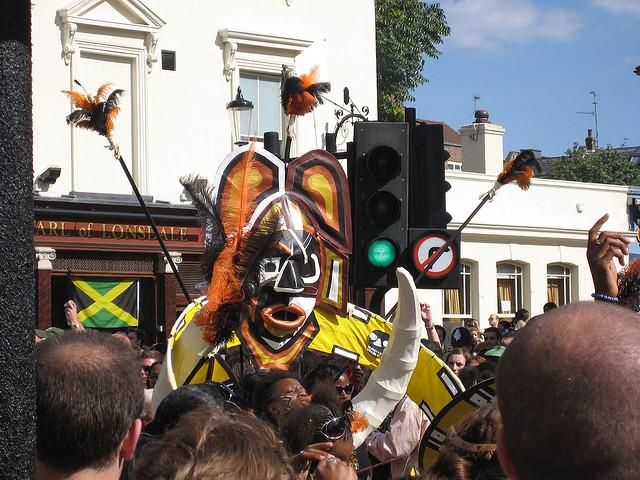The flag of what nation is visible in the background?
Answer briefly. Jamaica. What does the green light mean?
Give a very brief answer. Go. Does the costume have a person in it?
Short answer required. Yes. 